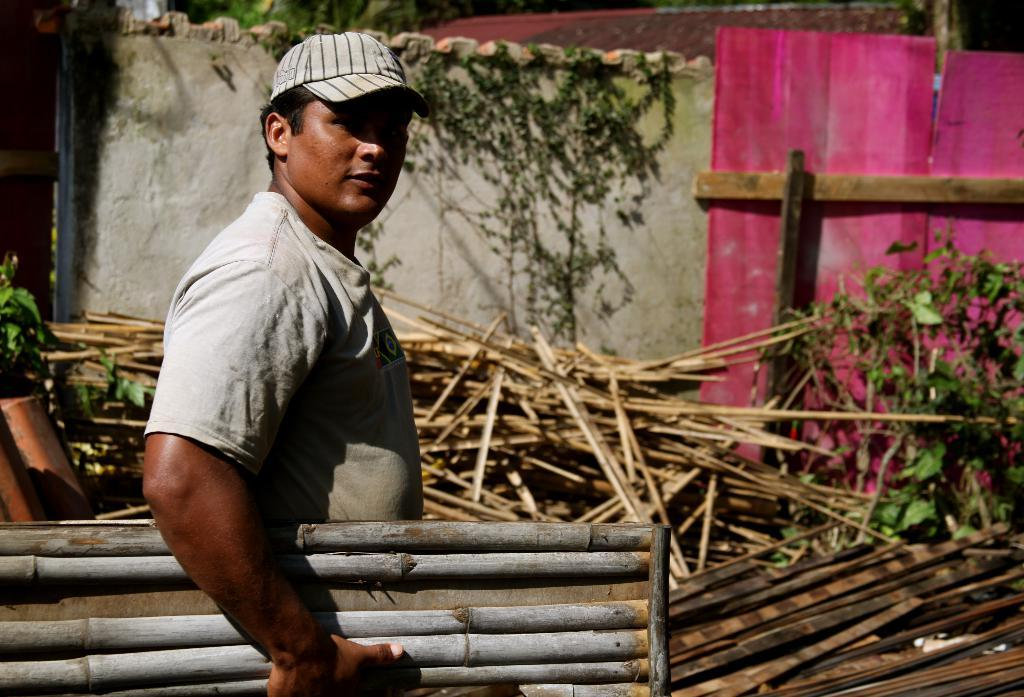What is the person in the image holding? The person is holding sticks in the image. What else can be seen in the background of the image? There are sticks, plants, and a wall visible in the background of the image. What is the color of the board in the image? The board in the image is pink. What type of butter is being used to plot the key on the color board in the image? There is no butter, plotting, or key present in the image. The image features a person holding sticks, background elements, and a pink color board. 